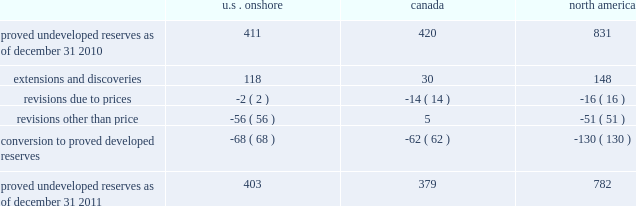Devon energy corporation and subsidiaries notes to consolidated financial statements 2014 ( continued ) proved undeveloped reserves the table presents the changes in our total proved undeveloped reserves during 2011 ( in mmboe ) . .
At december 31 , 2011 , devon had 782 mmboe of proved undeveloped reserves .
This represents a 6% ( 6 % ) decrease as compared to 2010 and represents 26% ( 26 % ) of its total proved reserves .
Drilling activities increased devon 2019s proved undeveloped reserves 148 mmboe and resulted in the conversion of 130 mmboe , or 16% ( 16 % ) , of the 2010 proved undeveloped reserves to proved developed reserves .
Additionally , revisions other than price decreased devon 2019s proved undeveloped reserves 51 mmboe primarily due to its evaluation of certain u.s .
Onshore dry-gas areas , which it does not expect to develop in the next five years .
The largest revisions relate to the dry-gas areas at carthage in east texas and the barnett shale in north texas .
A significant amount of devon 2019s proved undeveloped reserves at the end of 2011 largely related to its jackfish operations .
At december 31 , 2011 and 2010 , devon 2019s jackfish proved undeveloped reserves were 367 mmboe and 396 mmboe , respectively .
Development schedules for the jackfish reserves are primarily controlled by the need to keep the processing plants at their 35000 barrel daily facility capacity .
Processing plant capacity is controlled by factors such as total steam processing capacity , steam-oil ratios and air quality discharge permits .
As a result , these reserves are classified as proved undeveloped for more than five years .
Currently , the development schedule for these reserves extends though the year 2025 .
Price revisions 2011 2014reserves decreased 21 mmboe due to lower gas prices and higher oil prices .
The higher oil prices increased devon 2019s canadian royalty burden , which reduced devon 2019s oil reserves .
2010 2014reserves increased 72 mmboe due to higher gas prices , partially offset by the effect of higher oil prices .
The higher oil prices increased devon 2019s canadian royalty burden , which reduced devon 2019s oil reserves .
Of the 72 mmboe price revisions , 43 mmboe related to the barnett shale and 22 mmboe related to the rocky mountain area .
2009 2014reserves increased 177 mmboe due to higher oil prices , partially offset by lower gas prices .
The increase in oil reserves primarily related to devon 2019s jackfish thermal heavy oil reserves in canada .
At the end of 2008 , 331 mmboe of reserves related to jackfish were not considered proved .
However , due to higher prices , these reserves were considered proved as of december 31 , 2009 .
Significantly lower gas prices caused devon 2019s reserves to decrease 116 mmboe , which primarily related to its u.s .
Reserves .
Revisions other than price total revisions other than price for 2011 primarily related to devon 2019s evaluation of certain dry gas regions noted in the proved undeveloped reserves discussion above .
Total revisions other than price for 2010 and 2009 primarily related to devon 2019s drilling and development in the barnett shale. .
What was the percent of the proved undeveloped reserves in u.s . onshore as of december 31 2010 in north america? 
Computations: (411 / 831)
Answer: 0.49458. 